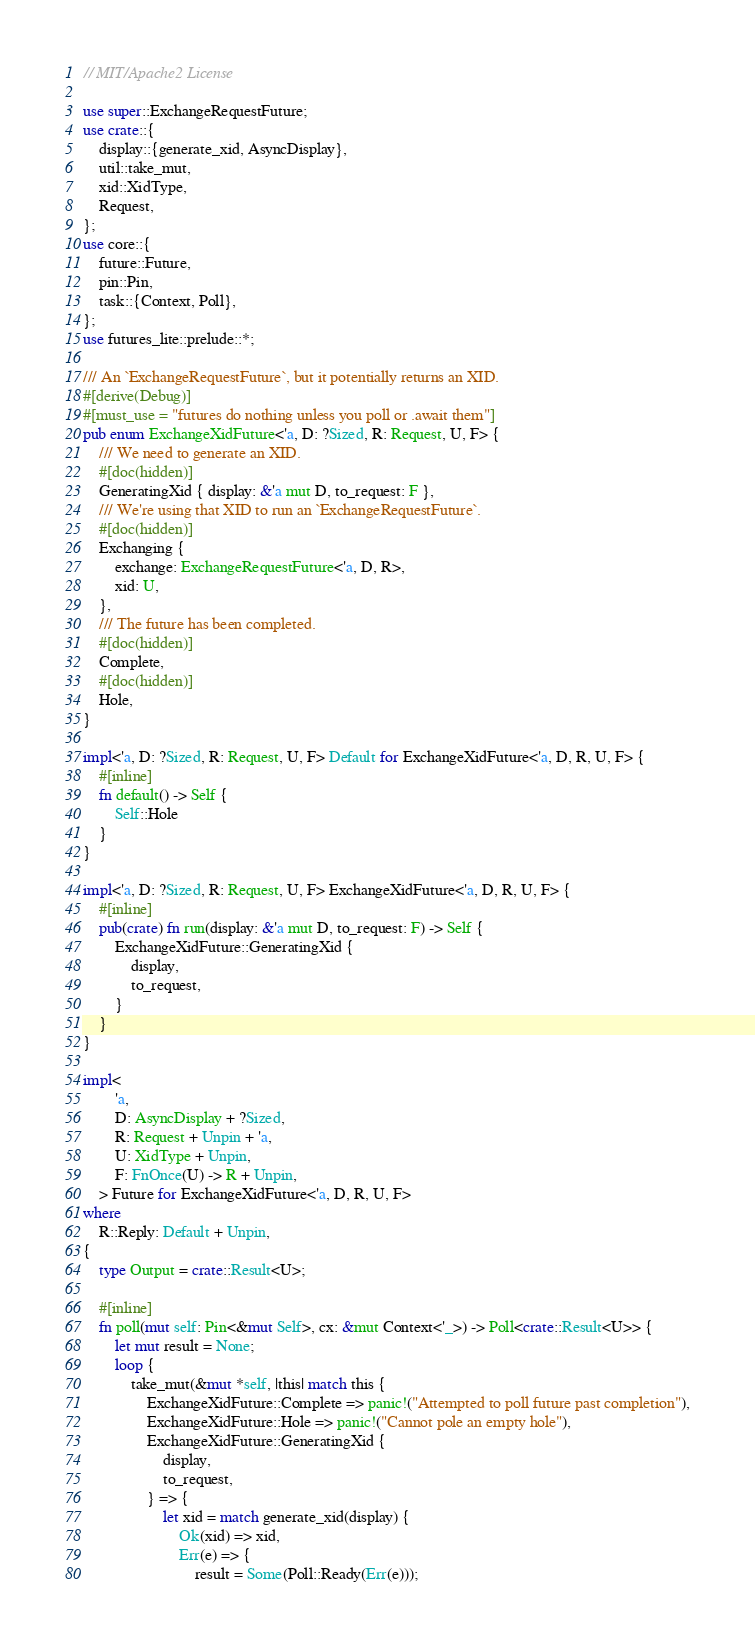Convert code to text. <code><loc_0><loc_0><loc_500><loc_500><_Rust_>// MIT/Apache2 License

use super::ExchangeRequestFuture;
use crate::{
    display::{generate_xid, AsyncDisplay},
    util::take_mut,
    xid::XidType,
    Request,
};
use core::{
    future::Future,
    pin::Pin,
    task::{Context, Poll},
};
use futures_lite::prelude::*;

/// An `ExchangeRequestFuture`, but it potentially returns an XID.
#[derive(Debug)]
#[must_use = "futures do nothing unless you poll or .await them"]
pub enum ExchangeXidFuture<'a, D: ?Sized, R: Request, U, F> {
    /// We need to generate an XID.
    #[doc(hidden)]
    GeneratingXid { display: &'a mut D, to_request: F },
    /// We're using that XID to run an `ExchangeRequestFuture`.
    #[doc(hidden)]
    Exchanging {
        exchange: ExchangeRequestFuture<'a, D, R>,
        xid: U,
    },
    /// The future has been completed.
    #[doc(hidden)]
    Complete,
    #[doc(hidden)]
    Hole,
}

impl<'a, D: ?Sized, R: Request, U, F> Default for ExchangeXidFuture<'a, D, R, U, F> {
    #[inline]
    fn default() -> Self {
        Self::Hole
    }
}

impl<'a, D: ?Sized, R: Request, U, F> ExchangeXidFuture<'a, D, R, U, F> {
    #[inline]
    pub(crate) fn run(display: &'a mut D, to_request: F) -> Self {
        ExchangeXidFuture::GeneratingXid {
            display,
            to_request,
        }
    }
}

impl<
        'a,
        D: AsyncDisplay + ?Sized,
        R: Request + Unpin + 'a,
        U: XidType + Unpin,
        F: FnOnce(U) -> R + Unpin,
    > Future for ExchangeXidFuture<'a, D, R, U, F>
where
    R::Reply: Default + Unpin,
{
    type Output = crate::Result<U>;

    #[inline]
    fn poll(mut self: Pin<&mut Self>, cx: &mut Context<'_>) -> Poll<crate::Result<U>> {
        let mut result = None;
        loop {
            take_mut(&mut *self, |this| match this {
                ExchangeXidFuture::Complete => panic!("Attempted to poll future past completion"),
                ExchangeXidFuture::Hole => panic!("Cannot pole an empty hole"),
                ExchangeXidFuture::GeneratingXid {
                    display,
                    to_request,
                } => {
                    let xid = match generate_xid(display) {
                        Ok(xid) => xid,
                        Err(e) => {
                            result = Some(Poll::Ready(Err(e)));</code> 